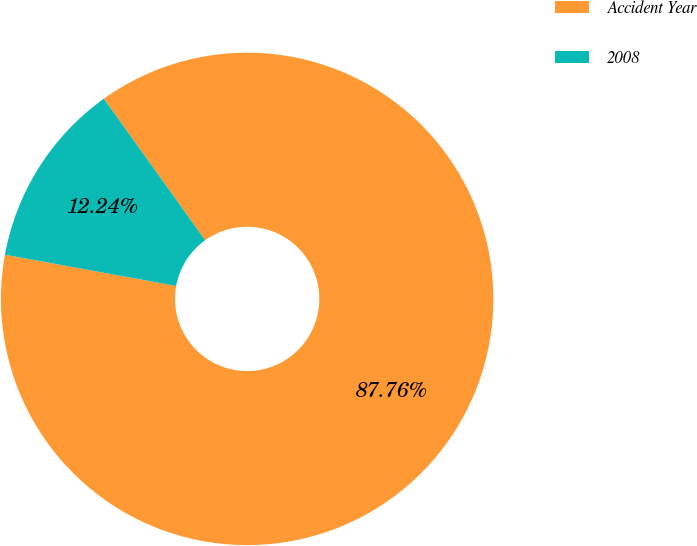Convert chart to OTSL. <chart><loc_0><loc_0><loc_500><loc_500><pie_chart><fcel>Accident Year<fcel>2008<nl><fcel>87.76%<fcel>12.24%<nl></chart> 